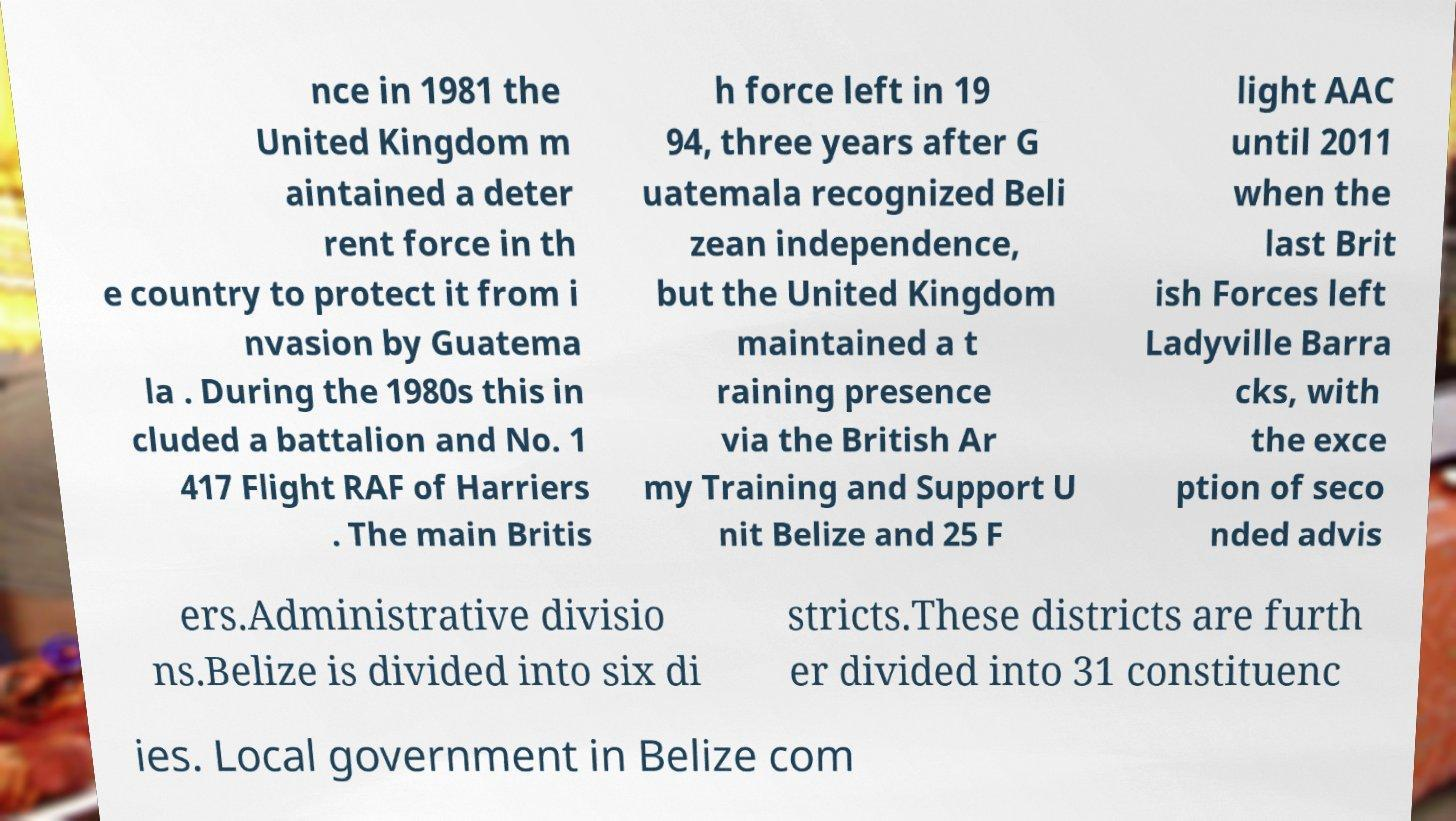For documentation purposes, I need the text within this image transcribed. Could you provide that? nce in 1981 the United Kingdom m aintained a deter rent force in th e country to protect it from i nvasion by Guatema la . During the 1980s this in cluded a battalion and No. 1 417 Flight RAF of Harriers . The main Britis h force left in 19 94, three years after G uatemala recognized Beli zean independence, but the United Kingdom maintained a t raining presence via the British Ar my Training and Support U nit Belize and 25 F light AAC until 2011 when the last Brit ish Forces left Ladyville Barra cks, with the exce ption of seco nded advis ers.Administrative divisio ns.Belize is divided into six di stricts.These districts are furth er divided into 31 constituenc ies. Local government in Belize com 